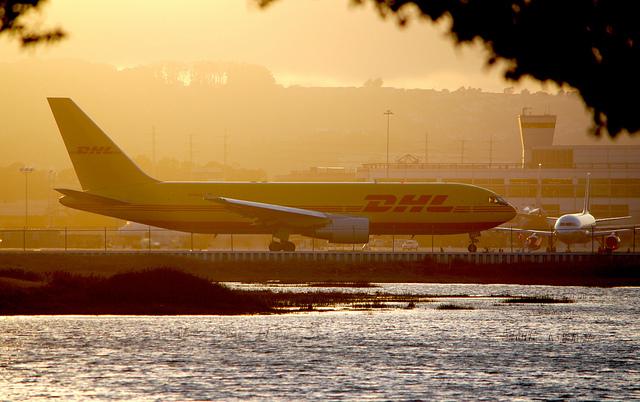What does this plane transport?
Be succinct. Packages. Is this plane yellow?
Give a very brief answer. Yes. What airline logo is on the side of the jet?
Write a very short answer. Dhl. Is the plane in the water?
Quick response, please. No. 